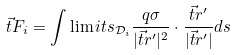<formula> <loc_0><loc_0><loc_500><loc_500>\vec { t } { F _ { i } } = \int \lim i t s _ { \mathcal { D } _ { i } } \frac { q \sigma } { | \vec { t } { r ^ { \prime } } | ^ { 2 } } \cdot \frac { \vec { t } { r ^ { \prime } } } { | \vec { t } { r ^ { \prime } } | } d s</formula> 